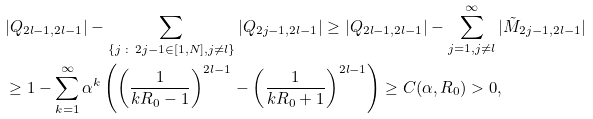<formula> <loc_0><loc_0><loc_500><loc_500>& | Q _ { 2 l - 1 , 2 l - 1 } | - \sum _ { \{ j \, \colon \, 2 j - 1 \in [ 1 , N ] , j \neq l \} } | Q _ { 2 j - 1 , 2 l - 1 } | \geq | Q _ { 2 l - 1 , 2 l - 1 } | - \sum _ { j = 1 , j \neq l } ^ { \infty } | \tilde { M } _ { 2 j - 1 , 2 l - 1 } | \\ & \geq 1 - \sum _ { k = 1 } ^ { \infty } \alpha ^ { k } \left ( \left ( \frac { 1 } { k R _ { 0 } - 1 } \right ) ^ { 2 l - 1 } - \left ( \frac { 1 } { k R _ { 0 } + 1 } \right ) ^ { 2 l - 1 } \right ) \geq C ( \alpha , R _ { 0 } ) > 0 ,</formula> 